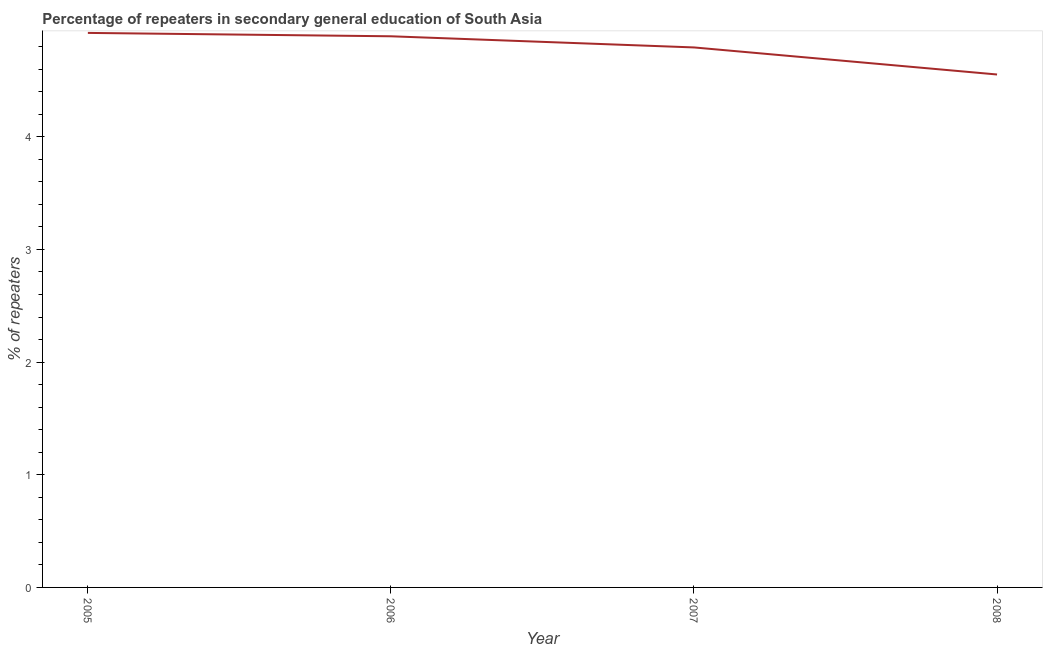What is the percentage of repeaters in 2007?
Offer a very short reply. 4.79. Across all years, what is the maximum percentage of repeaters?
Make the answer very short. 4.92. Across all years, what is the minimum percentage of repeaters?
Make the answer very short. 4.55. In which year was the percentage of repeaters maximum?
Give a very brief answer. 2005. In which year was the percentage of repeaters minimum?
Your response must be concise. 2008. What is the sum of the percentage of repeaters?
Give a very brief answer. 19.16. What is the difference between the percentage of repeaters in 2005 and 2008?
Keep it short and to the point. 0.37. What is the average percentage of repeaters per year?
Your answer should be compact. 4.79. What is the median percentage of repeaters?
Keep it short and to the point. 4.84. Do a majority of the years between 2006 and 2007 (inclusive) have percentage of repeaters greater than 2.2 %?
Offer a terse response. Yes. What is the ratio of the percentage of repeaters in 2006 to that in 2008?
Offer a very short reply. 1.07. What is the difference between the highest and the second highest percentage of repeaters?
Your response must be concise. 0.03. Is the sum of the percentage of repeaters in 2007 and 2008 greater than the maximum percentage of repeaters across all years?
Offer a terse response. Yes. What is the difference between the highest and the lowest percentage of repeaters?
Your answer should be very brief. 0.37. In how many years, is the percentage of repeaters greater than the average percentage of repeaters taken over all years?
Provide a succinct answer. 3. What is the difference between two consecutive major ticks on the Y-axis?
Ensure brevity in your answer.  1. Does the graph contain any zero values?
Provide a short and direct response. No. Does the graph contain grids?
Offer a very short reply. No. What is the title of the graph?
Your answer should be compact. Percentage of repeaters in secondary general education of South Asia. What is the label or title of the Y-axis?
Keep it short and to the point. % of repeaters. What is the % of repeaters in 2005?
Offer a very short reply. 4.92. What is the % of repeaters of 2006?
Make the answer very short. 4.89. What is the % of repeaters in 2007?
Provide a short and direct response. 4.79. What is the % of repeaters in 2008?
Give a very brief answer. 4.55. What is the difference between the % of repeaters in 2005 and 2006?
Provide a short and direct response. 0.03. What is the difference between the % of repeaters in 2005 and 2007?
Your answer should be compact. 0.13. What is the difference between the % of repeaters in 2005 and 2008?
Your answer should be compact. 0.37. What is the difference between the % of repeaters in 2006 and 2007?
Ensure brevity in your answer.  0.1. What is the difference between the % of repeaters in 2006 and 2008?
Give a very brief answer. 0.34. What is the difference between the % of repeaters in 2007 and 2008?
Make the answer very short. 0.24. What is the ratio of the % of repeaters in 2005 to that in 2007?
Give a very brief answer. 1.03. What is the ratio of the % of repeaters in 2005 to that in 2008?
Offer a very short reply. 1.08. What is the ratio of the % of repeaters in 2006 to that in 2008?
Provide a succinct answer. 1.07. What is the ratio of the % of repeaters in 2007 to that in 2008?
Offer a terse response. 1.05. 